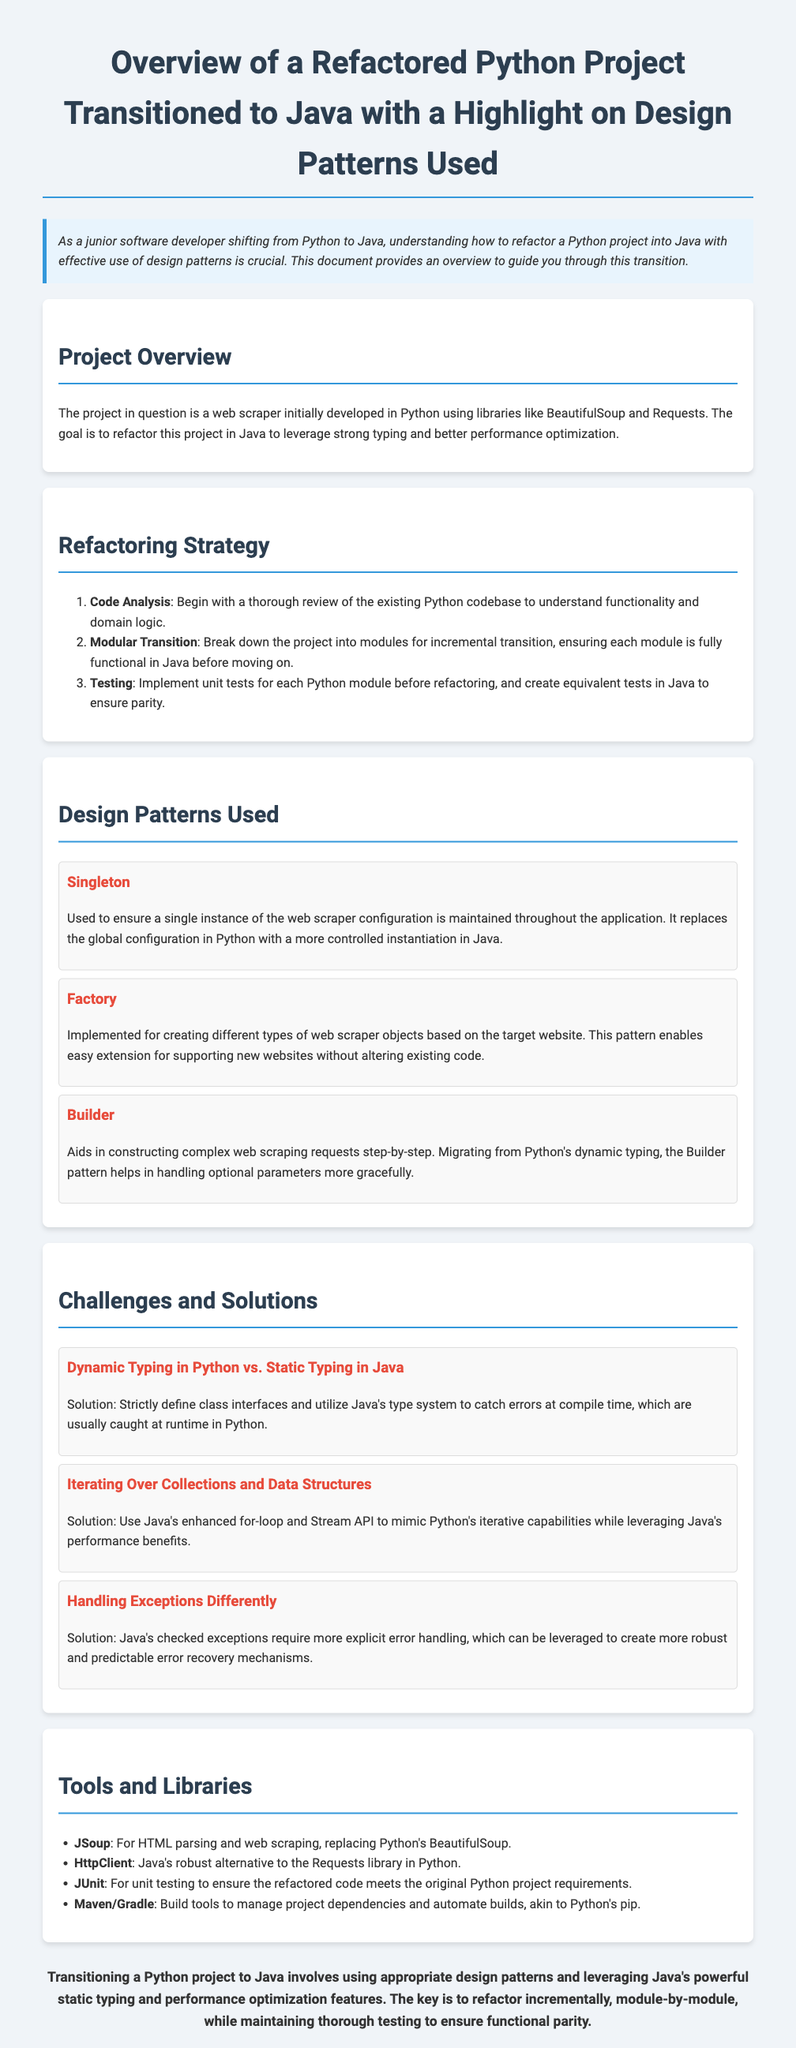What is the title of the document? The title is mentioned at the top of the document.
Answer: Overview of a Refactored Python Project Transitioned to Java with a Highlight on Design Patterns Used What design pattern is used to create different types of web scraper objects? The document specifies that a Factory pattern is used for this purpose.
Answer: Factory Which library in Java replaces BeautifulSoup from Python? The document lists JSoup as the replacement for BeautifulSoup.
Answer: JSoup What challenge is associated with dynamic typing in Python? The document highlights the transition from dynamic typing in Python to static typing in Java as a challenge.
Answer: Dynamic Typing How many main sections does the document have? The document outlines five main sections, including the introduction.
Answer: Five What strategy is recommended for transitioning the code? The document mentions "Modular Transition" as one of the strategies for the refactor.
Answer: Modular Transition What tool is suggested for unit testing in Java? The document indicates that JUnit is used for unit testing.
Answer: JUnit What is the conclusion regarding the transition process? The document summarizes that incremental refactoring and thorough testing are key.
Answer: Incremental refactoring and thorough testing Which design pattern helps in constructing complex web scraping requests? The document states that the Builder pattern is used for this purpose.
Answer: Builder 